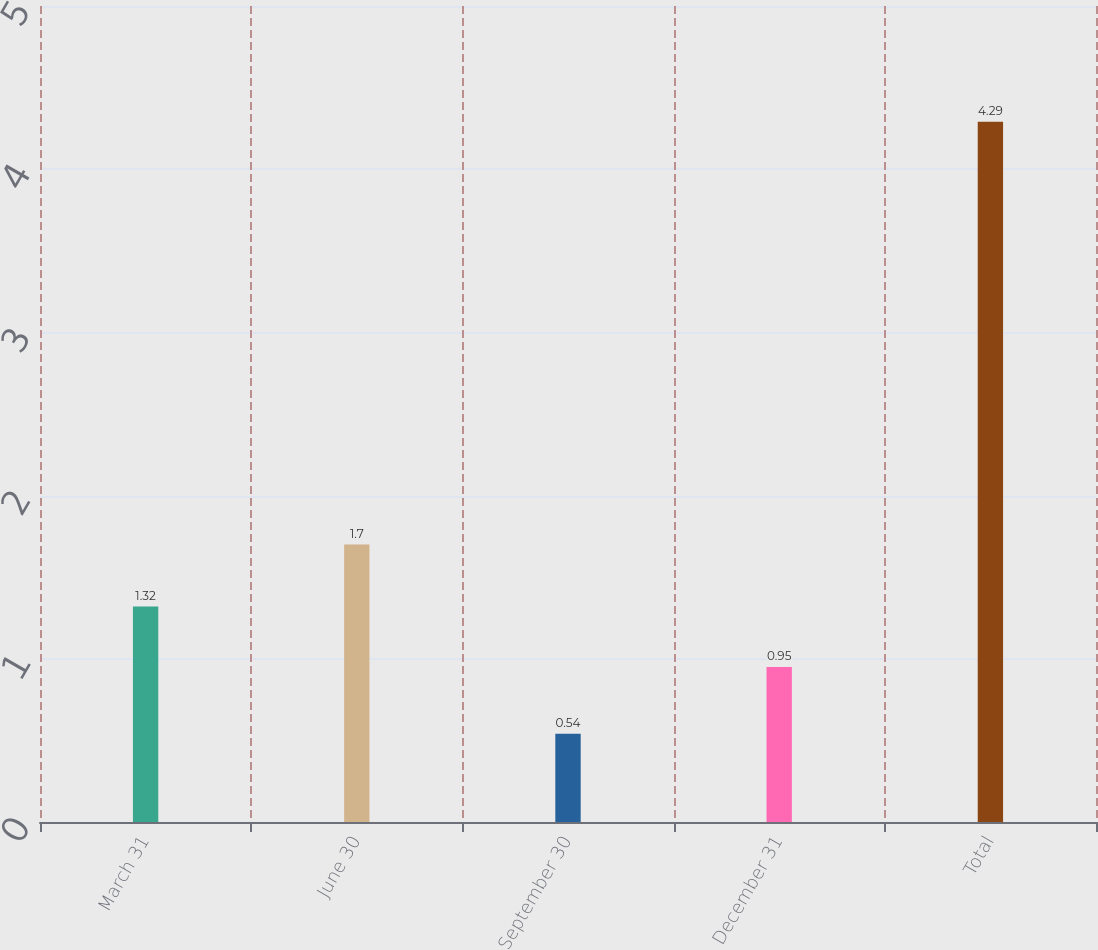<chart> <loc_0><loc_0><loc_500><loc_500><bar_chart><fcel>March 31<fcel>June 30<fcel>September 30<fcel>December 31<fcel>Total<nl><fcel>1.32<fcel>1.7<fcel>0.54<fcel>0.95<fcel>4.29<nl></chart> 